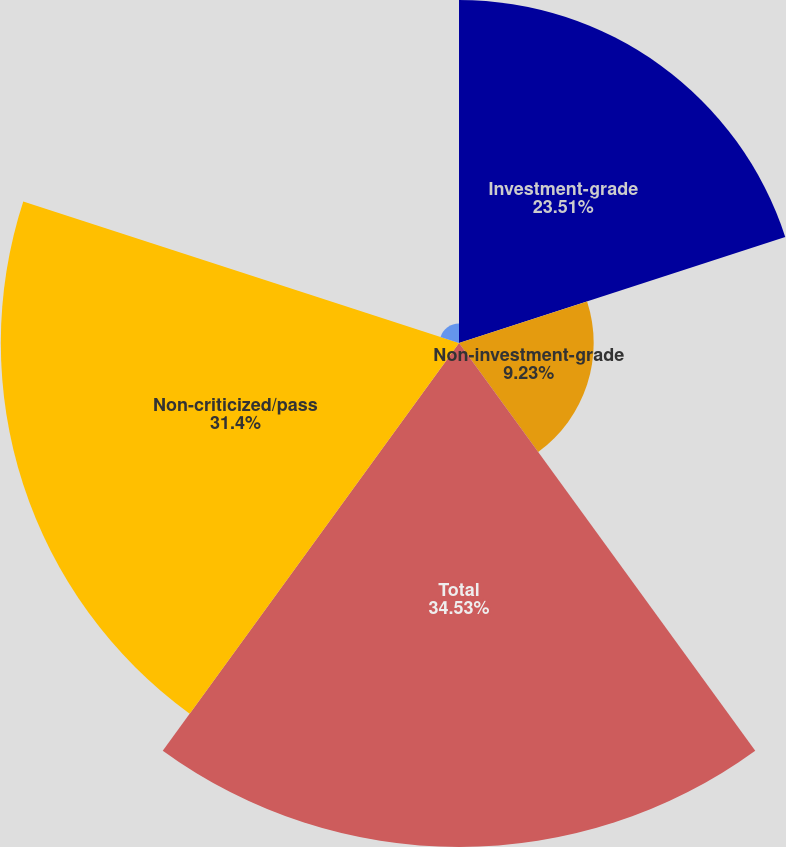<chart> <loc_0><loc_0><loc_500><loc_500><pie_chart><fcel>Investment-grade<fcel>Non-investment-grade<fcel>Total<fcel>Non-criticized/pass<fcel>Criticized<nl><fcel>23.51%<fcel>9.23%<fcel>34.54%<fcel>31.4%<fcel>1.33%<nl></chart> 